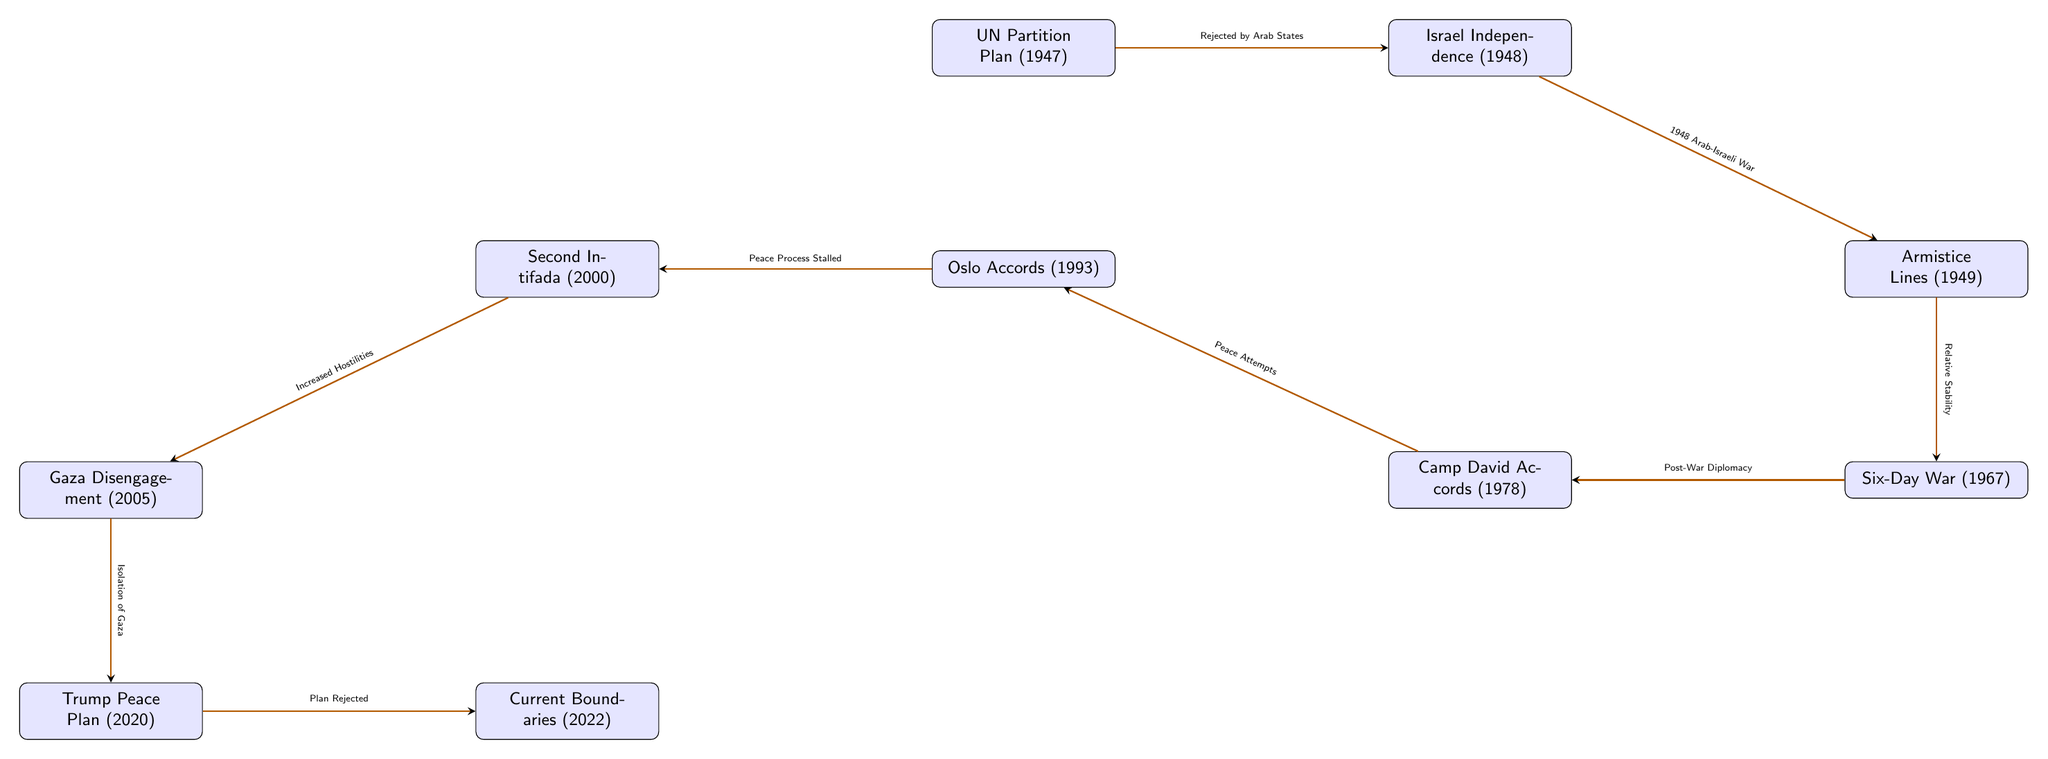What is the first event in the diagram? The first event listed in the diagram is the UN Partition Plan of 1947, as it is positioned at the beginning of the timeline.
Answer: UN Partition Plan (1947) How many significant events are depicted in the diagram? By counting the event nodes in the diagram, there are ten significant events, each representing a crucial moment in the Israel-Palestine conflict timeline.
Answer: 10 What transition follows the Armistice Lines event? The transition leading from the Armistice Lines (1949) is towards the Six-Day War (1967), which indicates that the subsequent event is directly connected to the earlier one.
Answer: Six-Day War (1967) What caused the change from the Oslo Accords to the Second Intifada? The transition between these two events states "Peace Process Stalled," indicating that this was the primary factor that led to the Second Intifada occurring after the Oslo Accords.
Answer: Peace Process Stalled Which event marks Israel’s independence? The event that marks Israel’s independence, as depicted in the diagram, is labeled as Israel Independence (1948). This event is directly after the UN Partition Plan.
Answer: Israel Independence (1948) What event occurred directly before the Gaza Disengagement? The event that occurred right before the Gaza Disengagement (2005) is the Second Intifada (2000), which indicates a progression of events leading up to the disengagement.
Answer: Second Intifada (2000) What is the label used for the transition from the Six-Day War to the Camp David Accords? The transition label connecting these two events is "Post-War Diplomacy," indicating the nature of the relationship between the events.
Answer: Post-War Diplomacy What event is indicated as the most recent in the diagram? The most recent event depicted in the diagram, showing current boundaries, is labeled as Current Boundaries (2022), reflecting the latest developments in the timeline of events.
Answer: Current Boundaries (2022) What factor led to the Isolation of Gaza? The transition from the Gaza Disengagement (2005) to the Trump Peace Plan (2020) reflects "Isolation of Gaza" as the factor impacting the subsequent developments.
Answer: Isolation of Gaza 